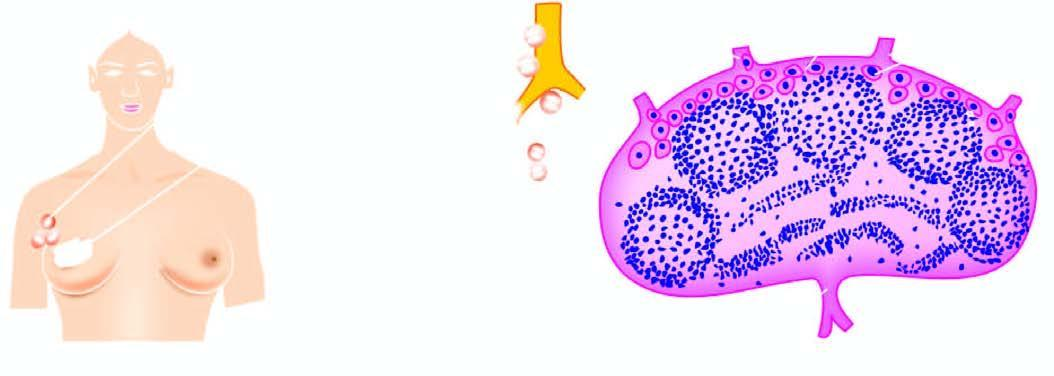what begins by lodgement of tumour cells in subcapsular sinus via afferent lymphatics entering at the convex surface of the lymph node?
Answer the question using a single word or phrase. Lymphatic spread 